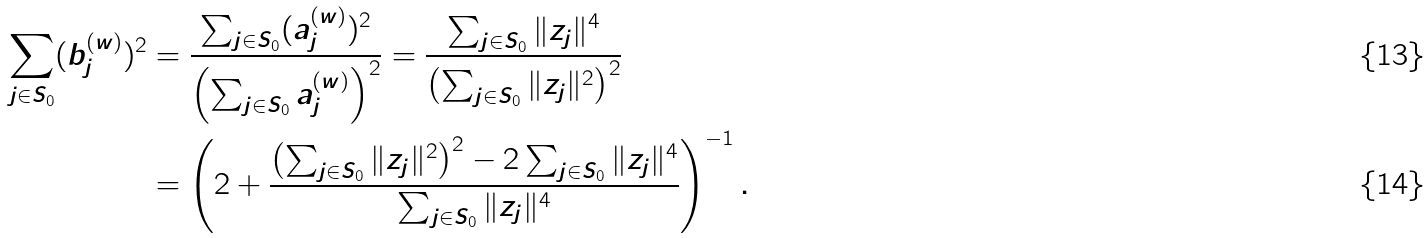Convert formula to latex. <formula><loc_0><loc_0><loc_500><loc_500>\sum _ { j \in S _ { 0 } } ( b _ { j } ^ { ( w ) } ) ^ { 2 } & = \frac { \sum _ { j \in S _ { 0 } } ( a _ { j } ^ { ( w ) } ) ^ { 2 } } { \left ( \sum _ { j \in S _ { 0 } } a _ { j } ^ { ( w ) } \right ) ^ { 2 } } = \frac { \sum _ { j \in S _ { 0 } } \| z _ { j } \| ^ { 4 } } { \left ( \sum _ { j \in S _ { 0 } } \| z _ { j } \| ^ { 2 } \right ) ^ { 2 } } \\ & = \left ( 2 + \frac { \left ( \sum _ { j \in S _ { 0 } } \| z _ { j } \| ^ { 2 } \right ) ^ { 2 } - 2 \sum _ { j \in S _ { 0 } } \| z _ { j } \| ^ { 4 } } { \sum _ { j \in S _ { 0 } } \| z _ { j } \| ^ { 4 } } \right ) ^ { - 1 } .</formula> 